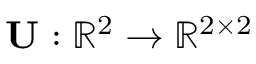<formula> <loc_0><loc_0><loc_500><loc_500>U \colon \mathbb { R } ^ { 2 } \rightarrow \mathbb { R } ^ { 2 \times 2 }</formula> 